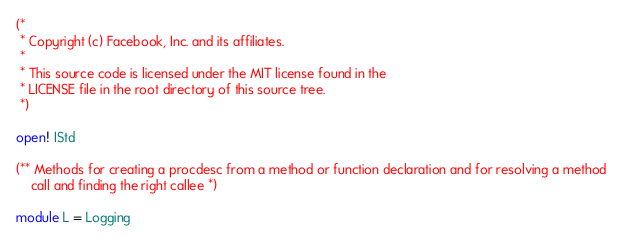Convert code to text. <code><loc_0><loc_0><loc_500><loc_500><_OCaml_>(*
 * Copyright (c) Facebook, Inc. and its affiliates.
 *
 * This source code is licensed under the MIT license found in the
 * LICENSE file in the root directory of this source tree.
 *)

open! IStd

(** Methods for creating a procdesc from a method or function declaration and for resolving a method
    call and finding the right callee *)

module L = Logging
</code> 